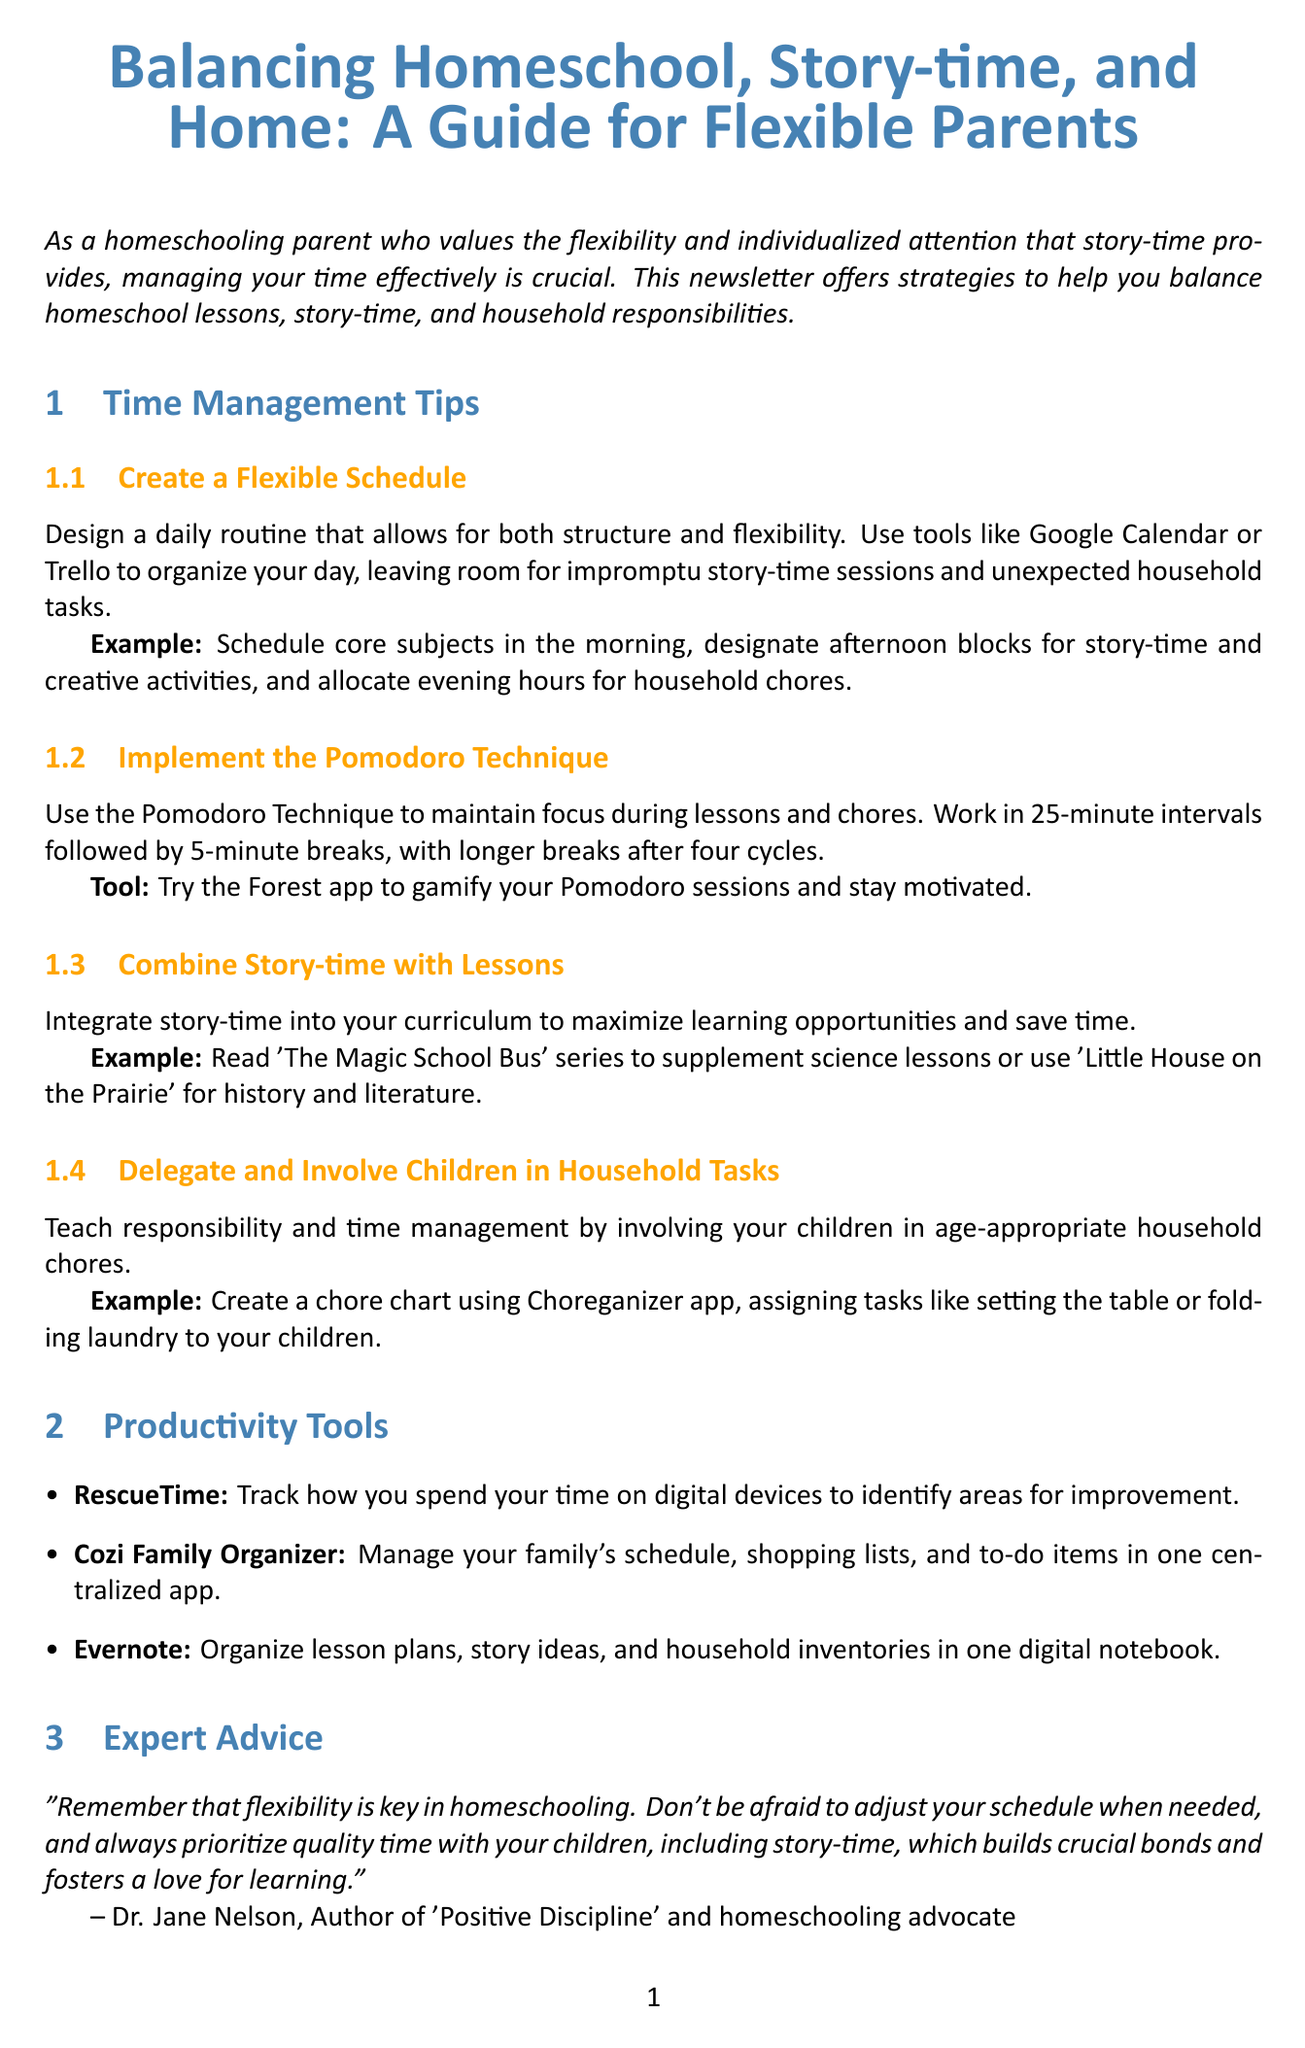What is the title of the newsletter? The title is given at the beginning of the document, summarizing the content focus.
Answer: Balancing Homeschool, Story-time, and Home: A Guide for Flexible Parents Who is the expert featured in the document? The expert's name is mentioned in the Expert Advice section, emphasizing their authority on the subject of homeschooling.
Answer: Dr. Jane Nelson What is one suggested productivity tool? The document lists tools designed to help organize and manage time, highlighting three specific tools.
Answer: RescueTime What date is the upcoming event scheduled for? The date of the workshop is provided in the Upcoming Event section, allowing readers to save the date.
Answer: May 15, 2023 What technique is recommended to maintain focus during lessons? A specific time management technique is mentioned that helps with focus, providing a structured approach to work.
Answer: Pomodoro Technique Which family is spotlighted in the community section? The Community Spotlight section includes a family's success story, showcasing practical applications of the strategies discussed.
Answer: The Johnson Family What is one example of combining story-time with lessons? The document provides examples of how story-time can be integrated with learning subjects to enhance education.
Answer: The Magic School Bus What is the purpose of creating a flexible schedule? The introduction describes the overall aim of the newsletter, addressing the needs of homeschooling parents.
Answer: Balance homeschool lessons, story-time, and household responsibilities 